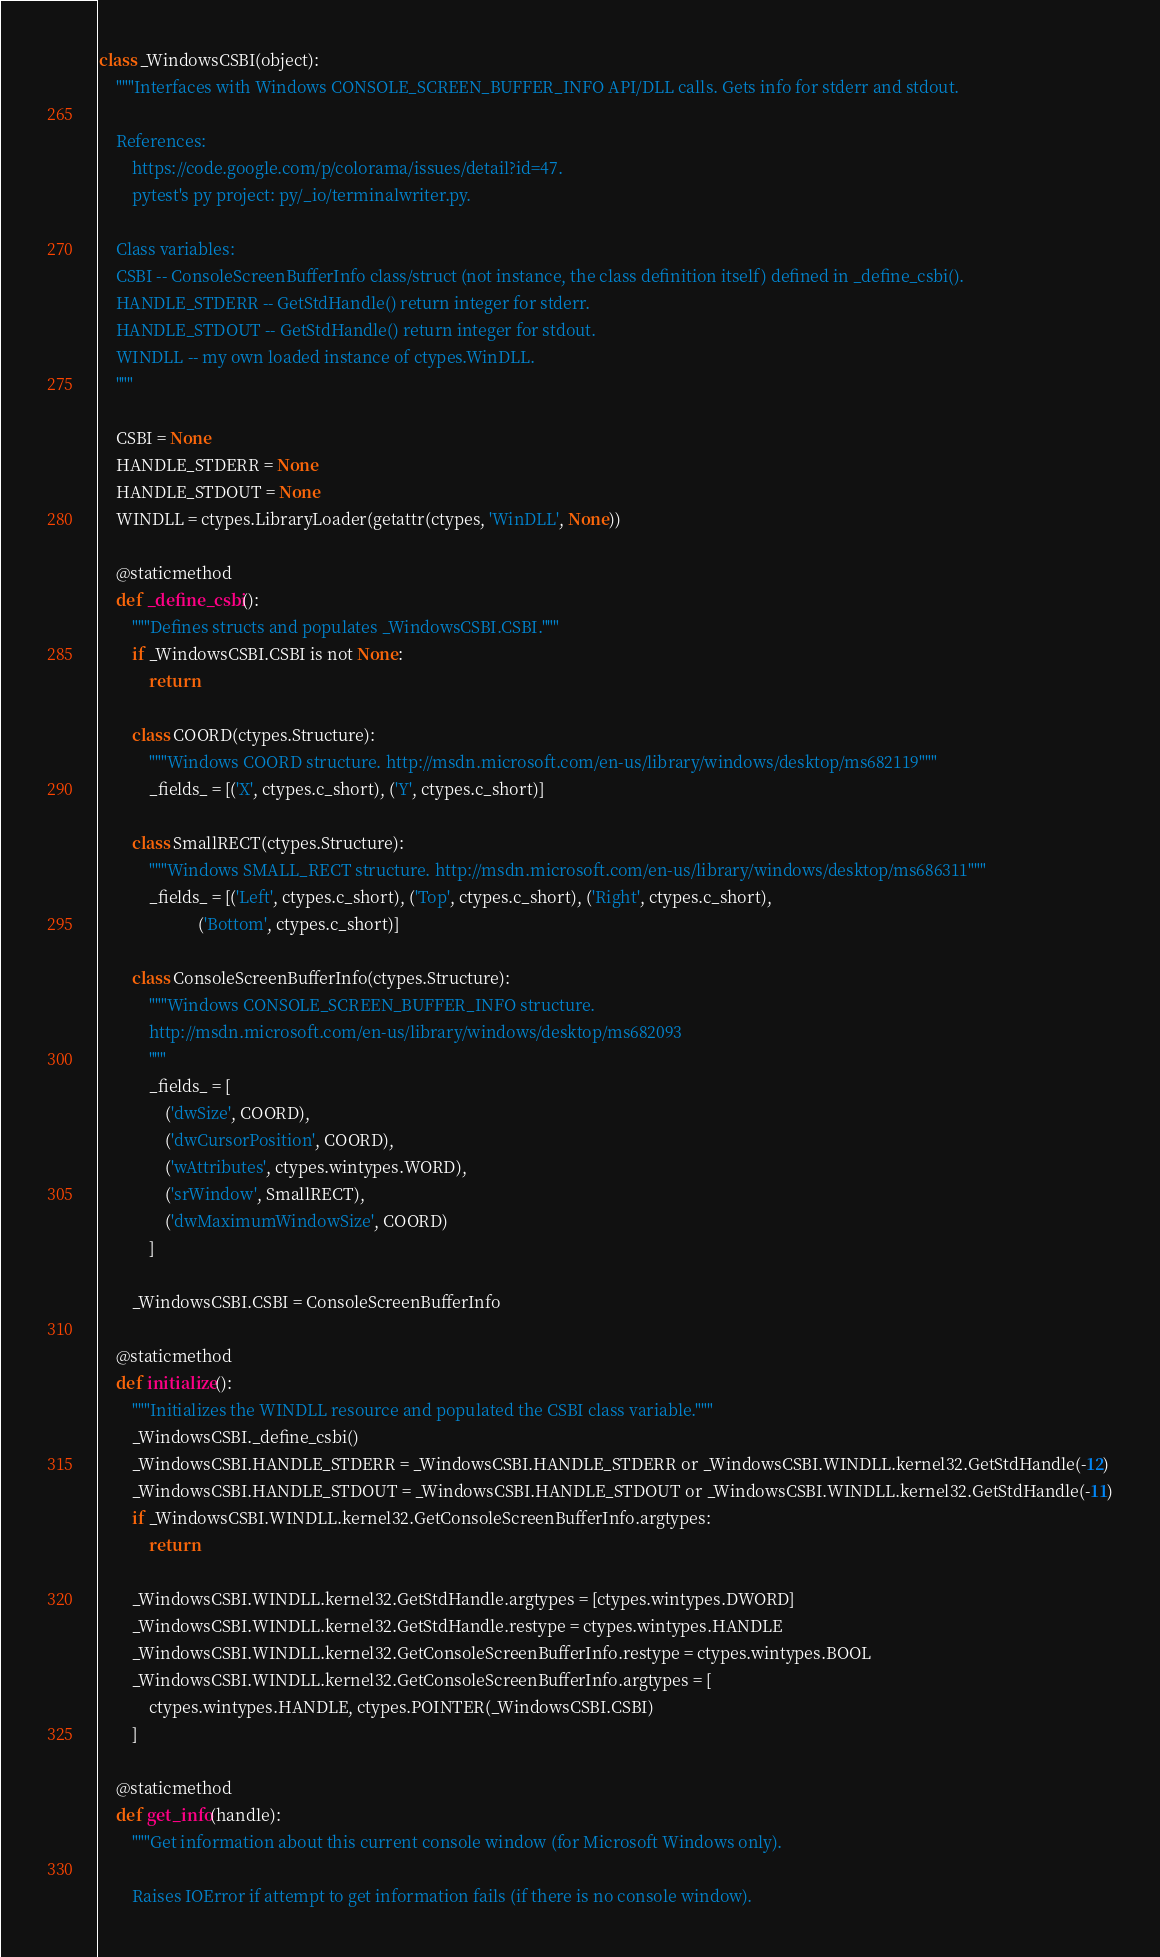Convert code to text. <code><loc_0><loc_0><loc_500><loc_500><_Python_>class _WindowsCSBI(object):
    """Interfaces with Windows CONSOLE_SCREEN_BUFFER_INFO API/DLL calls. Gets info for stderr and stdout.

    References:
        https://code.google.com/p/colorama/issues/detail?id=47.
        pytest's py project: py/_io/terminalwriter.py.

    Class variables:
    CSBI -- ConsoleScreenBufferInfo class/struct (not instance, the class definition itself) defined in _define_csbi().
    HANDLE_STDERR -- GetStdHandle() return integer for stderr.
    HANDLE_STDOUT -- GetStdHandle() return integer for stdout.
    WINDLL -- my own loaded instance of ctypes.WinDLL.
    """

    CSBI = None
    HANDLE_STDERR = None
    HANDLE_STDOUT = None
    WINDLL = ctypes.LibraryLoader(getattr(ctypes, 'WinDLL', None))

    @staticmethod
    def _define_csbi():
        """Defines structs and populates _WindowsCSBI.CSBI."""
        if _WindowsCSBI.CSBI is not None:
            return

        class COORD(ctypes.Structure):
            """Windows COORD structure. http://msdn.microsoft.com/en-us/library/windows/desktop/ms682119"""
            _fields_ = [('X', ctypes.c_short), ('Y', ctypes.c_short)]

        class SmallRECT(ctypes.Structure):
            """Windows SMALL_RECT structure. http://msdn.microsoft.com/en-us/library/windows/desktop/ms686311"""
            _fields_ = [('Left', ctypes.c_short), ('Top', ctypes.c_short), ('Right', ctypes.c_short),
                        ('Bottom', ctypes.c_short)]

        class ConsoleScreenBufferInfo(ctypes.Structure):
            """Windows CONSOLE_SCREEN_BUFFER_INFO structure.
            http://msdn.microsoft.com/en-us/library/windows/desktop/ms682093
            """
            _fields_ = [
                ('dwSize', COORD),
                ('dwCursorPosition', COORD),
                ('wAttributes', ctypes.wintypes.WORD),
                ('srWindow', SmallRECT),
                ('dwMaximumWindowSize', COORD)
            ]

        _WindowsCSBI.CSBI = ConsoleScreenBufferInfo

    @staticmethod
    def initialize():
        """Initializes the WINDLL resource and populated the CSBI class variable."""
        _WindowsCSBI._define_csbi()
        _WindowsCSBI.HANDLE_STDERR = _WindowsCSBI.HANDLE_STDERR or _WindowsCSBI.WINDLL.kernel32.GetStdHandle(-12)
        _WindowsCSBI.HANDLE_STDOUT = _WindowsCSBI.HANDLE_STDOUT or _WindowsCSBI.WINDLL.kernel32.GetStdHandle(-11)
        if _WindowsCSBI.WINDLL.kernel32.GetConsoleScreenBufferInfo.argtypes:
            return

        _WindowsCSBI.WINDLL.kernel32.GetStdHandle.argtypes = [ctypes.wintypes.DWORD]
        _WindowsCSBI.WINDLL.kernel32.GetStdHandle.restype = ctypes.wintypes.HANDLE
        _WindowsCSBI.WINDLL.kernel32.GetConsoleScreenBufferInfo.restype = ctypes.wintypes.BOOL
        _WindowsCSBI.WINDLL.kernel32.GetConsoleScreenBufferInfo.argtypes = [
            ctypes.wintypes.HANDLE, ctypes.POINTER(_WindowsCSBI.CSBI)
        ]

    @staticmethod
    def get_info(handle):
        """Get information about this current console window (for Microsoft Windows only).

        Raises IOError if attempt to get information fails (if there is no console window).
</code> 